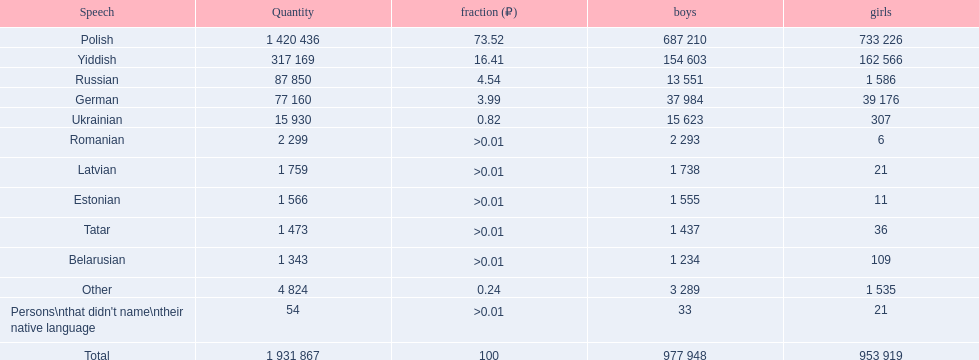What was the top language from the one's whose percentage was >0.01 Romanian. 